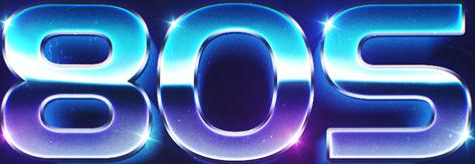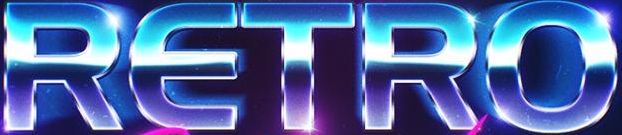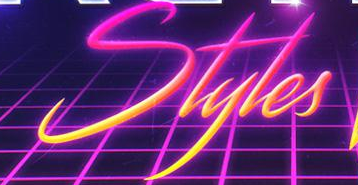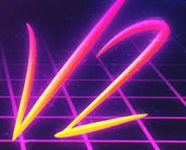What words are shown in these images in order, separated by a semicolon? 80S; RETRO; Styles; V2 